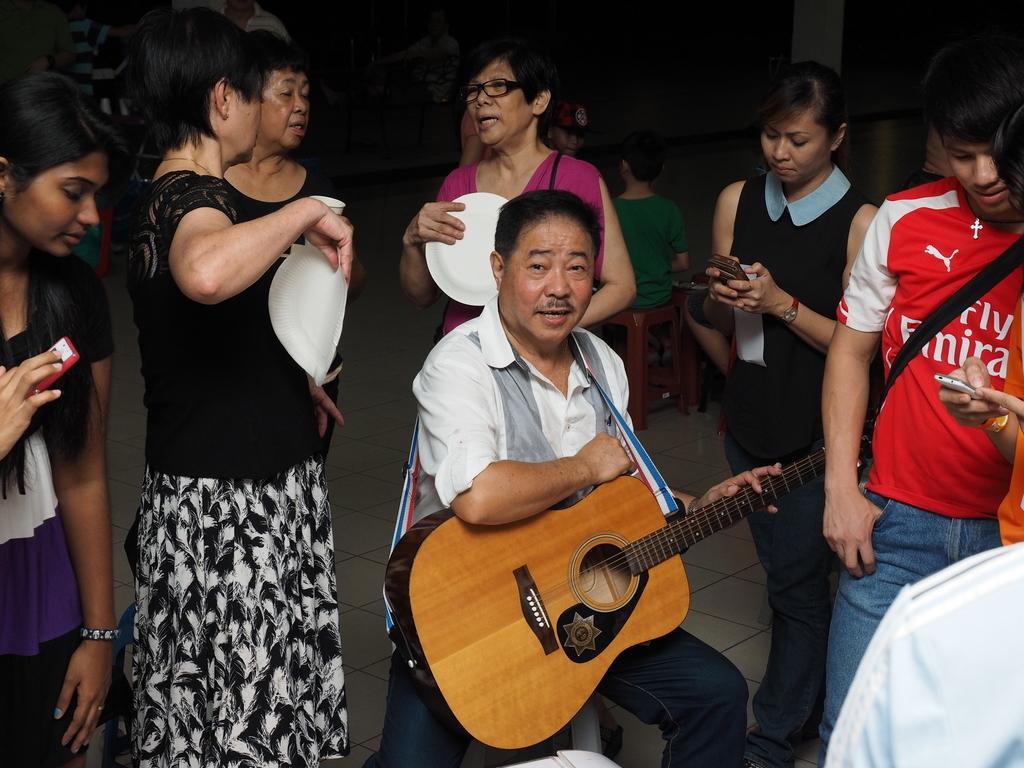In one or two sentences, can you explain what this image depicts? A man in white shirt is holding guitar. In the back there are many people standing. On the right a person in red t shirt is holding bag. Next to him a lady is holding a mobile. 